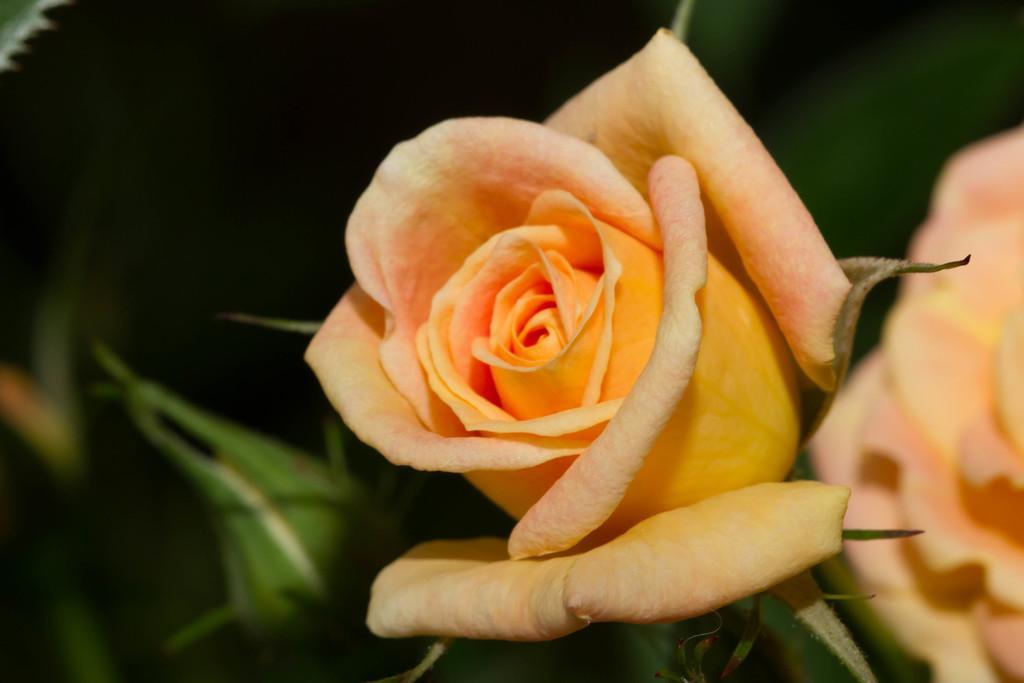Could you give a brief overview of what you see in this image? In this image I can see on the right side there are rose flowers. On the left side there is a bud. 